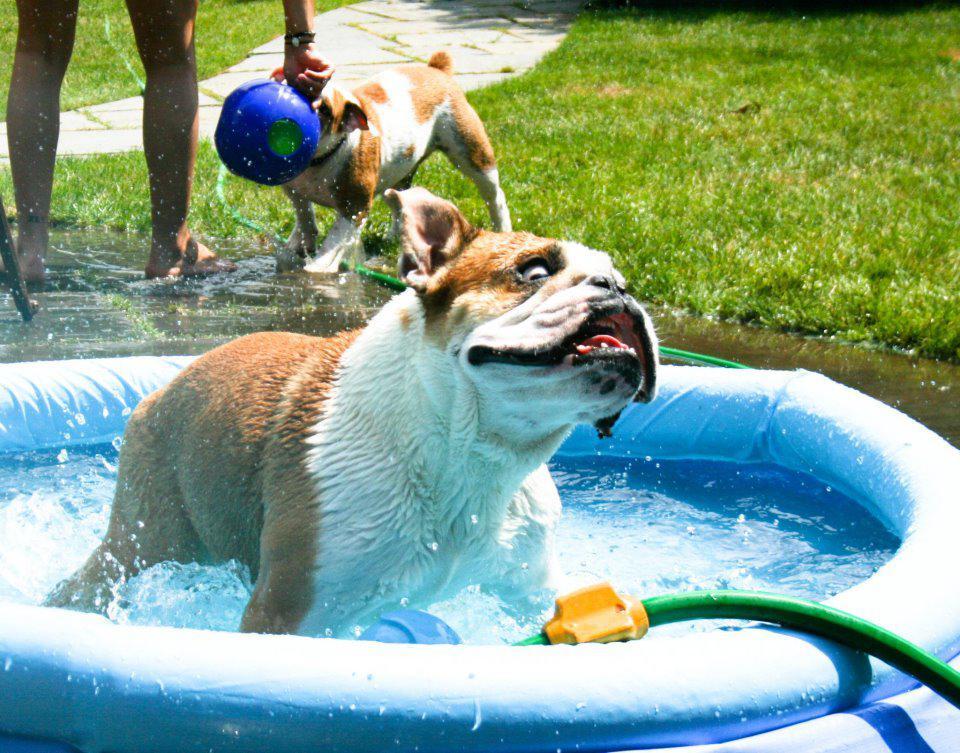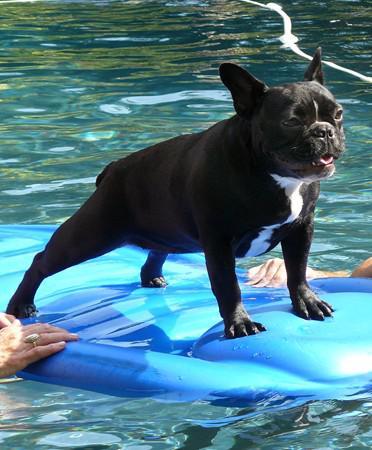The first image is the image on the left, the second image is the image on the right. Analyze the images presented: Is the assertion "A stout brown-and-white bulldog is by himself in a blue kiddie pool in one image, and the other image shows a dog that is above the water of a larger swimming pool." valid? Answer yes or no. Yes. The first image is the image on the left, the second image is the image on the right. For the images shown, is this caption "The left image contains at least two dogs." true? Answer yes or no. Yes. 